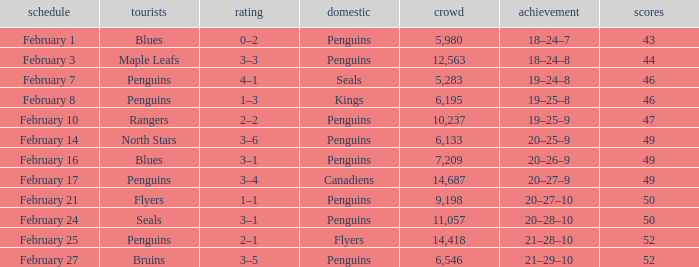Score of 2–1 has what record? 21–28–10. Parse the table in full. {'header': ['schedule', 'tourists', 'rating', 'domestic', 'crowd', 'achievement', 'scores'], 'rows': [['February 1', 'Blues', '0–2', 'Penguins', '5,980', '18–24–7', '43'], ['February 3', 'Maple Leafs', '3–3', 'Penguins', '12,563', '18–24–8', '44'], ['February 7', 'Penguins', '4–1', 'Seals', '5,283', '19–24–8', '46'], ['February 8', 'Penguins', '1–3', 'Kings', '6,195', '19–25–8', '46'], ['February 10', 'Rangers', '2–2', 'Penguins', '10,237', '19–25–9', '47'], ['February 14', 'North Stars', '3–6', 'Penguins', '6,133', '20–25–9', '49'], ['February 16', 'Blues', '3–1', 'Penguins', '7,209', '20–26–9', '49'], ['February 17', 'Penguins', '3–4', 'Canadiens', '14,687', '20–27–9', '49'], ['February 21', 'Flyers', '1–1', 'Penguins', '9,198', '20–27–10', '50'], ['February 24', 'Seals', '3–1', 'Penguins', '11,057', '20–28–10', '50'], ['February 25', 'Penguins', '2–1', 'Flyers', '14,418', '21–28–10', '52'], ['February 27', 'Bruins', '3–5', 'Penguins', '6,546', '21–29–10', '52']]} 